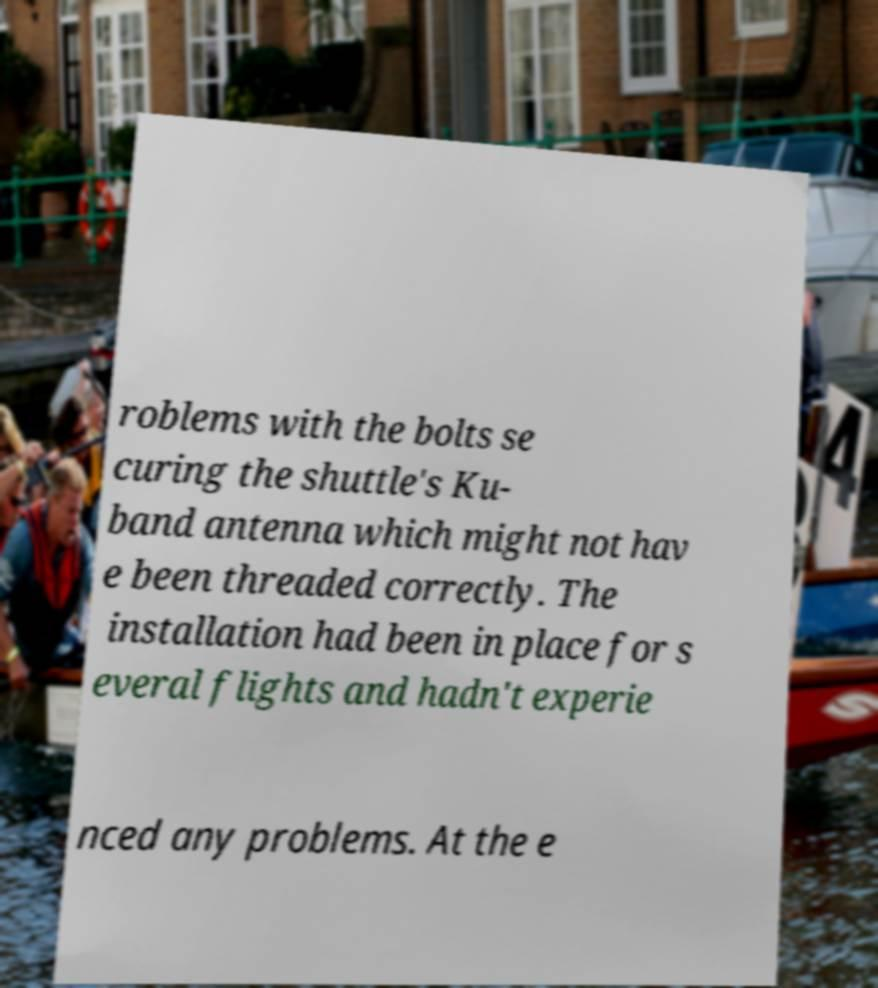For documentation purposes, I need the text within this image transcribed. Could you provide that? roblems with the bolts se curing the shuttle's Ku- band antenna which might not hav e been threaded correctly. The installation had been in place for s everal flights and hadn't experie nced any problems. At the e 